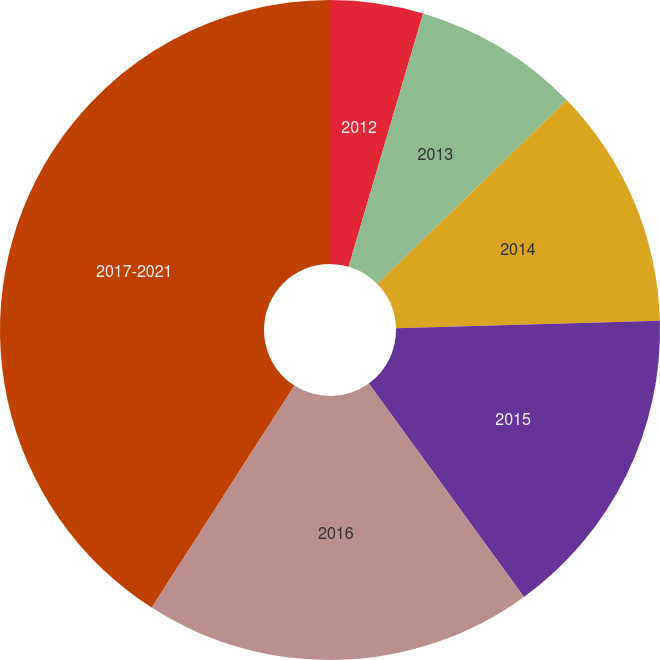Convert chart. <chart><loc_0><loc_0><loc_500><loc_500><pie_chart><fcel>2012<fcel>2013<fcel>2014<fcel>2015<fcel>2016<fcel>2017-2021<nl><fcel>4.55%<fcel>8.18%<fcel>11.82%<fcel>15.45%<fcel>19.09%<fcel>40.91%<nl></chart> 